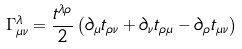Convert formula to latex. <formula><loc_0><loc_0><loc_500><loc_500>\Gamma ^ { \lambda } _ { \mu \nu } = \frac { t ^ { \lambda \rho } } { 2 } \left ( \partial _ { \mu } t _ { \rho \nu } + \partial _ { \nu } t _ { \rho \mu } - \partial _ { \rho } t _ { \mu \nu } \right )</formula> 